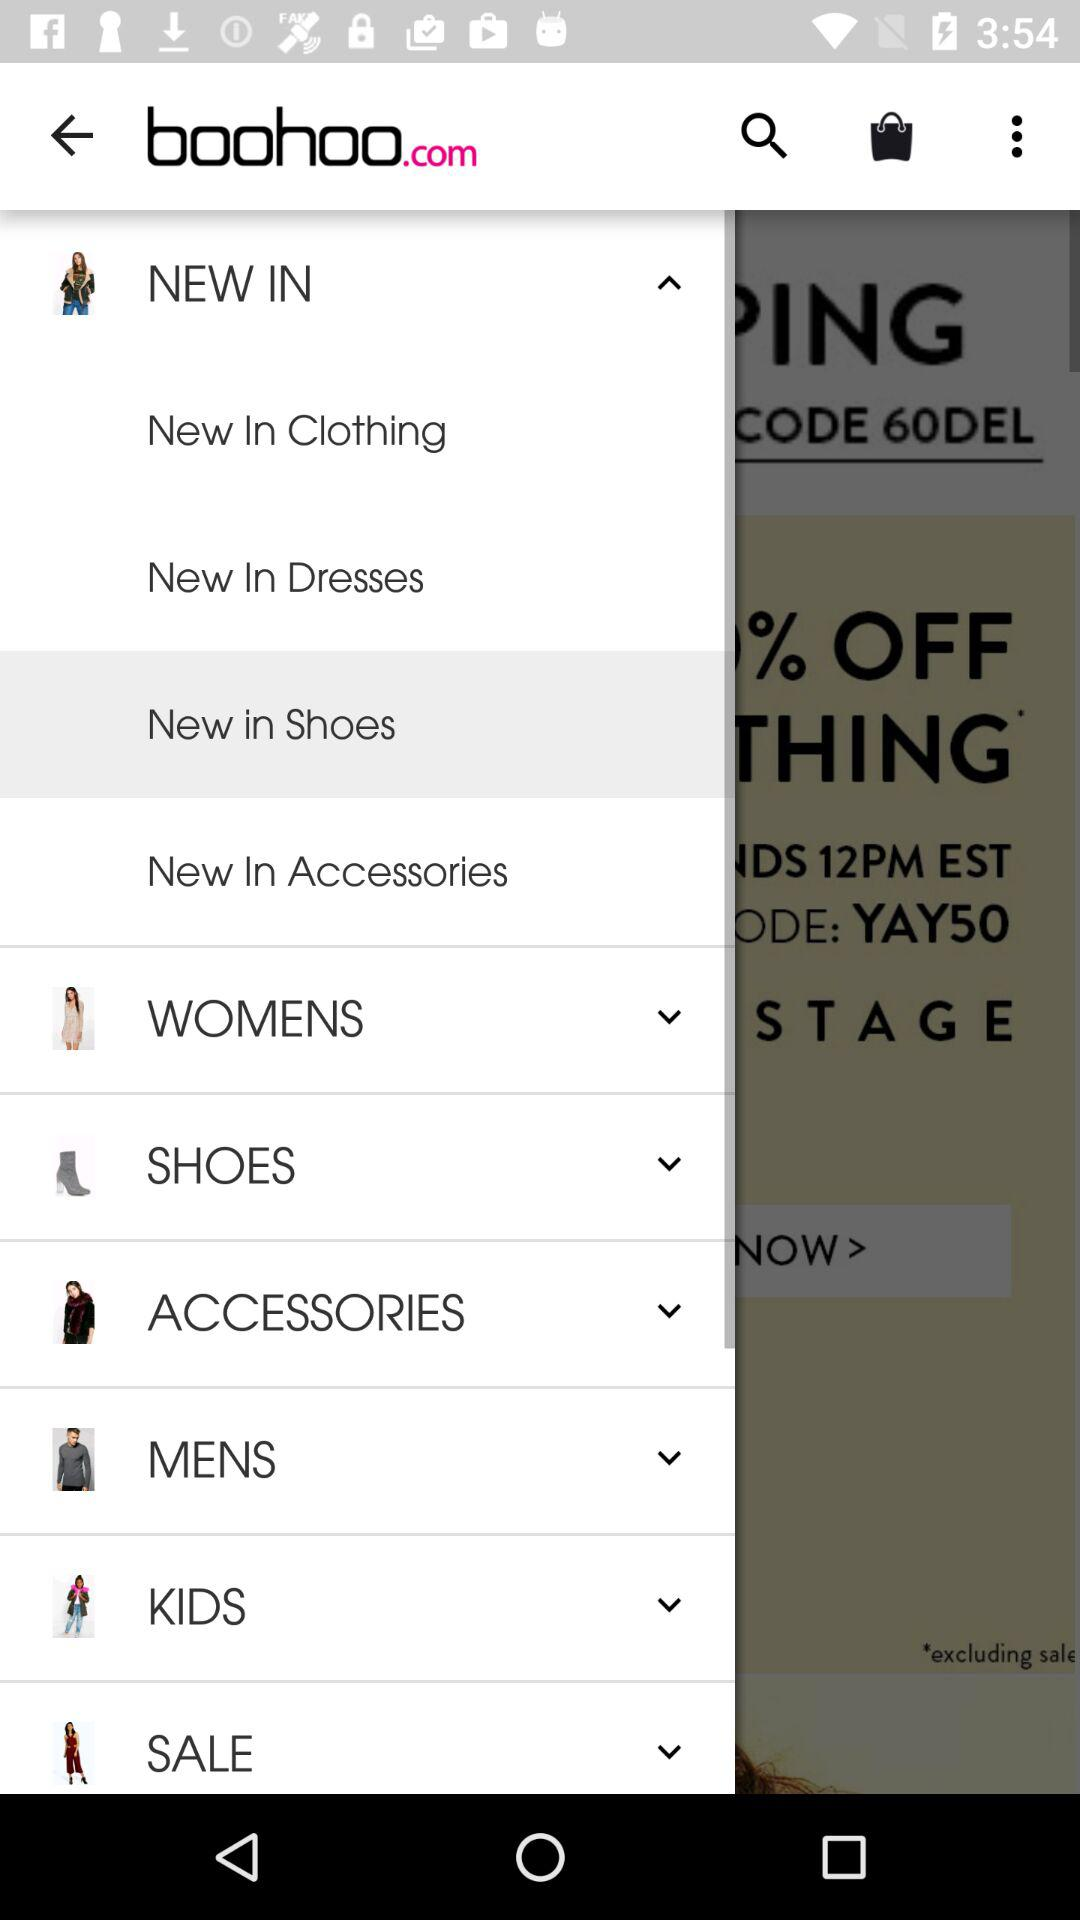Which item has been selected in the menu? The item "New in Shoes" is selected in the menu. 